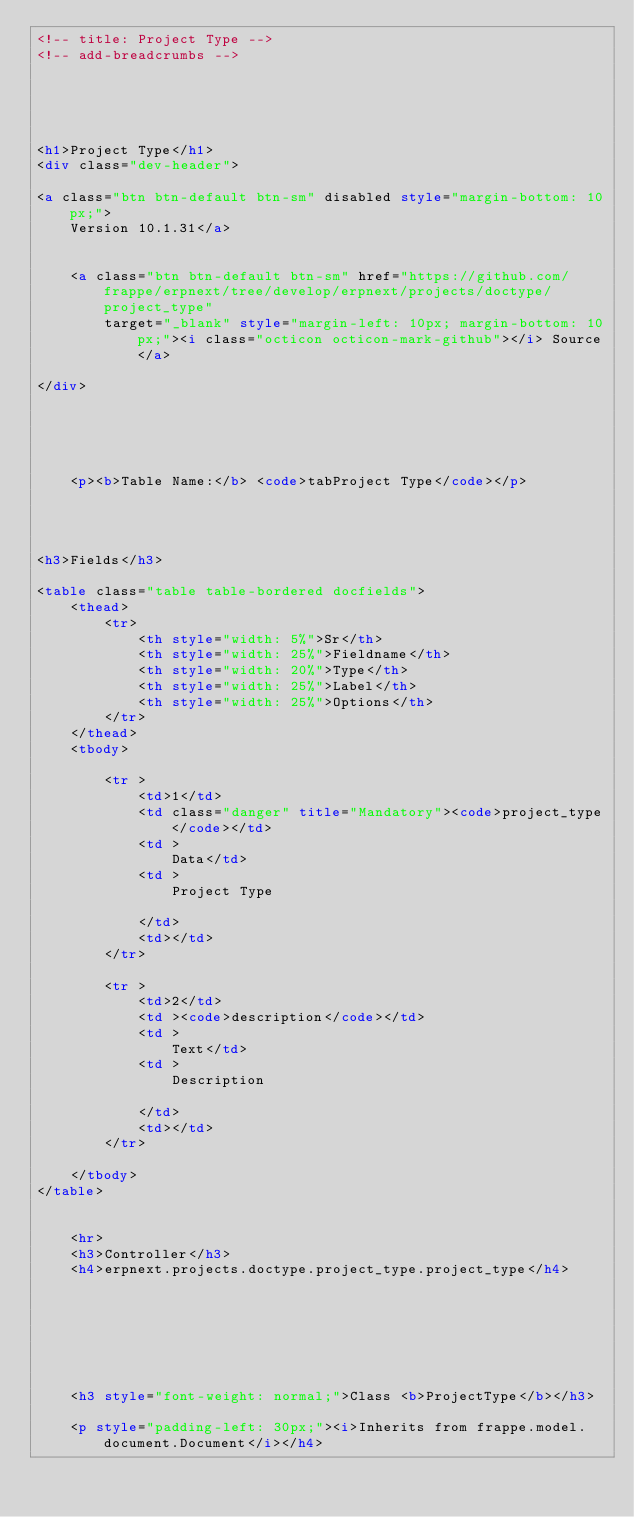<code> <loc_0><loc_0><loc_500><loc_500><_HTML_><!-- title: Project Type -->
<!-- add-breadcrumbs -->





<h1>Project Type</h1>
<div class="dev-header">

<a class="btn btn-default btn-sm" disabled style="margin-bottom: 10px;">
	Version 10.1.31</a>


	<a class="btn btn-default btn-sm" href="https://github.com/frappe/erpnext/tree/develop/erpnext/projects/doctype/project_type"
		target="_blank" style="margin-left: 10px; margin-bottom: 10px;"><i class="octicon octicon-mark-github"></i> Source</a>

</div>





    <p><b>Table Name:</b> <code>tabProject Type</code></p>




<h3>Fields</h3>

<table class="table table-bordered docfields">
    <thead>
        <tr>
            <th style="width: 5%">Sr</th>
            <th style="width: 25%">Fieldname</th>
            <th style="width: 20%">Type</th>
            <th style="width: 25%">Label</th>
            <th style="width: 25%">Options</th>
        </tr>
    </thead>
    <tbody>
        
        <tr >
            <td>1</td>
            <td class="danger" title="Mandatory"><code>project_type</code></td>
            <td >
                Data</td>
            <td >
                Project Type
                
            </td>
            <td></td>
        </tr>
        
        <tr >
            <td>2</td>
            <td ><code>description</code></td>
            <td >
                Text</td>
            <td >
                Description
                
            </td>
            <td></td>
        </tr>
        
    </tbody>
</table>


    <hr>
    <h3>Controller</h3>
    <h4>erpnext.projects.doctype.project_type.project_type</h4>

    



	
        
	<h3 style="font-weight: normal;">Class <b>ProjectType</b></h3>
    
    <p style="padding-left: 30px;"><i>Inherits from frappe.model.document.Document</i></h4>
    </code> 